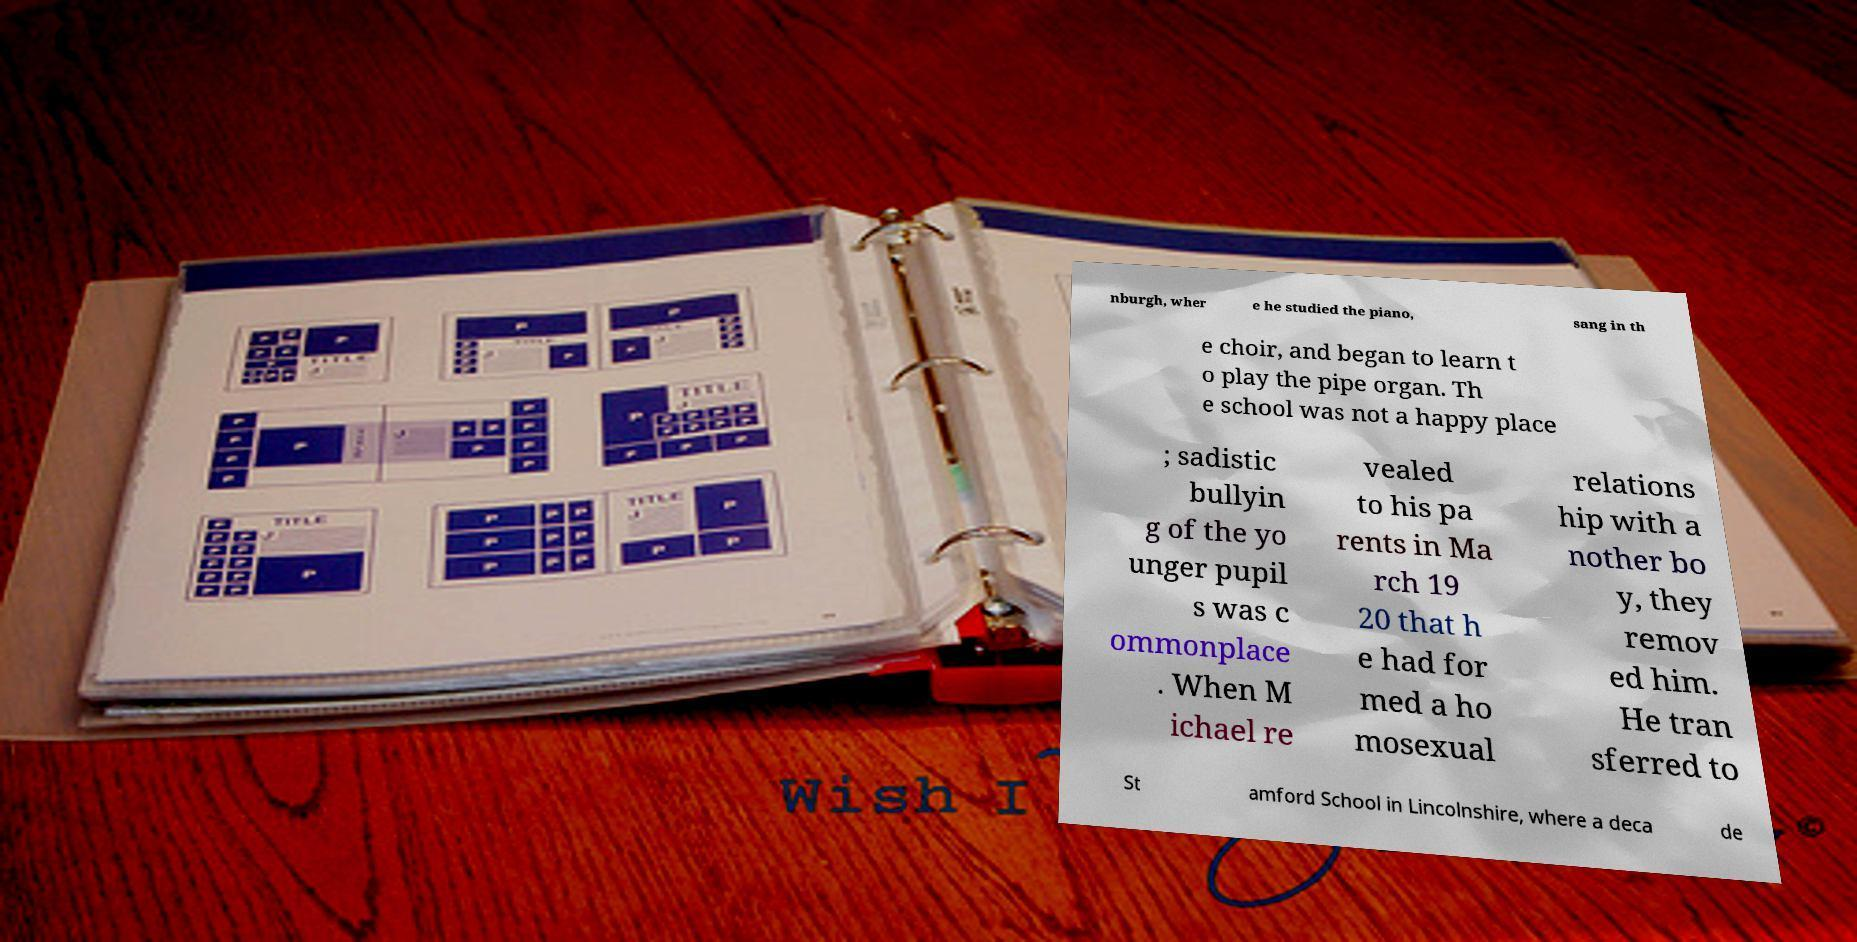I need the written content from this picture converted into text. Can you do that? nburgh, wher e he studied the piano, sang in th e choir, and began to learn t o play the pipe organ. Th e school was not a happy place ; sadistic bullyin g of the yo unger pupil s was c ommonplace . When M ichael re vealed to his pa rents in Ma rch 19 20 that h e had for med a ho mosexual relations hip with a nother bo y, they remov ed him. He tran sferred to St amford School in Lincolnshire, where a deca de 